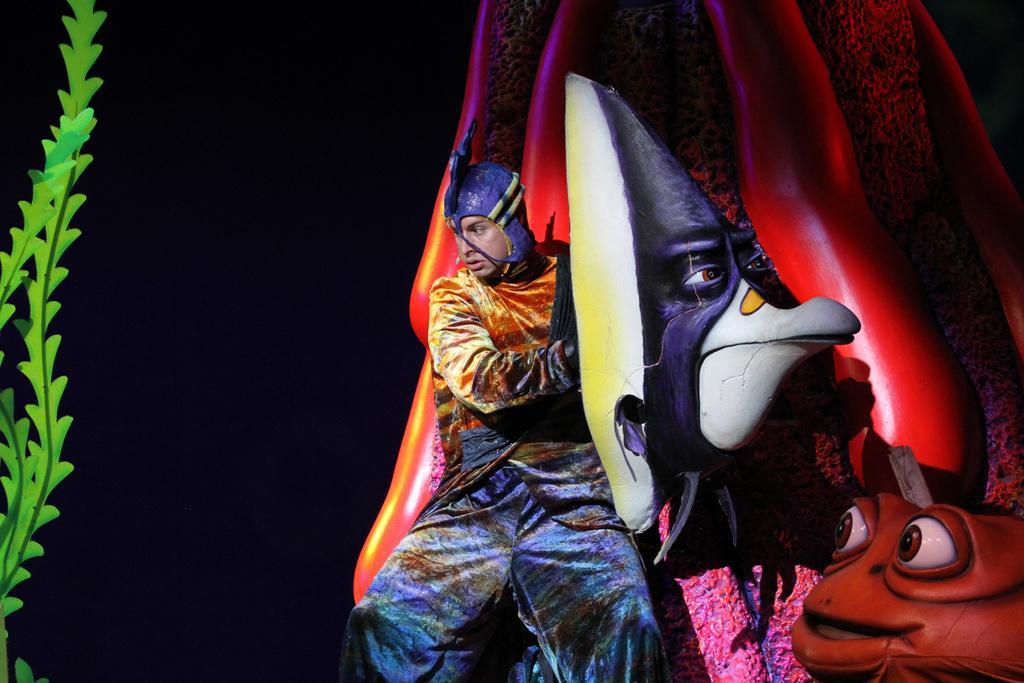Could you give a brief overview of what you see in this image? In this image I can see a person sitting and the person is wearing multi color dress, background I can see a multi color toy and I can see a plant in green color and I can see dark background. 